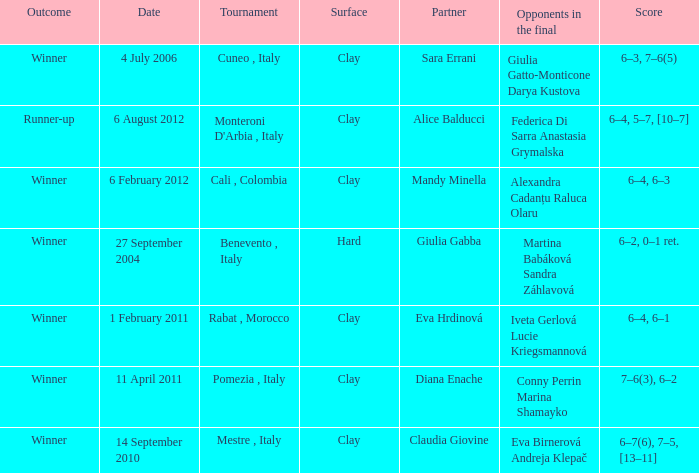Who played on a hard surface? Giulia Gabba. 